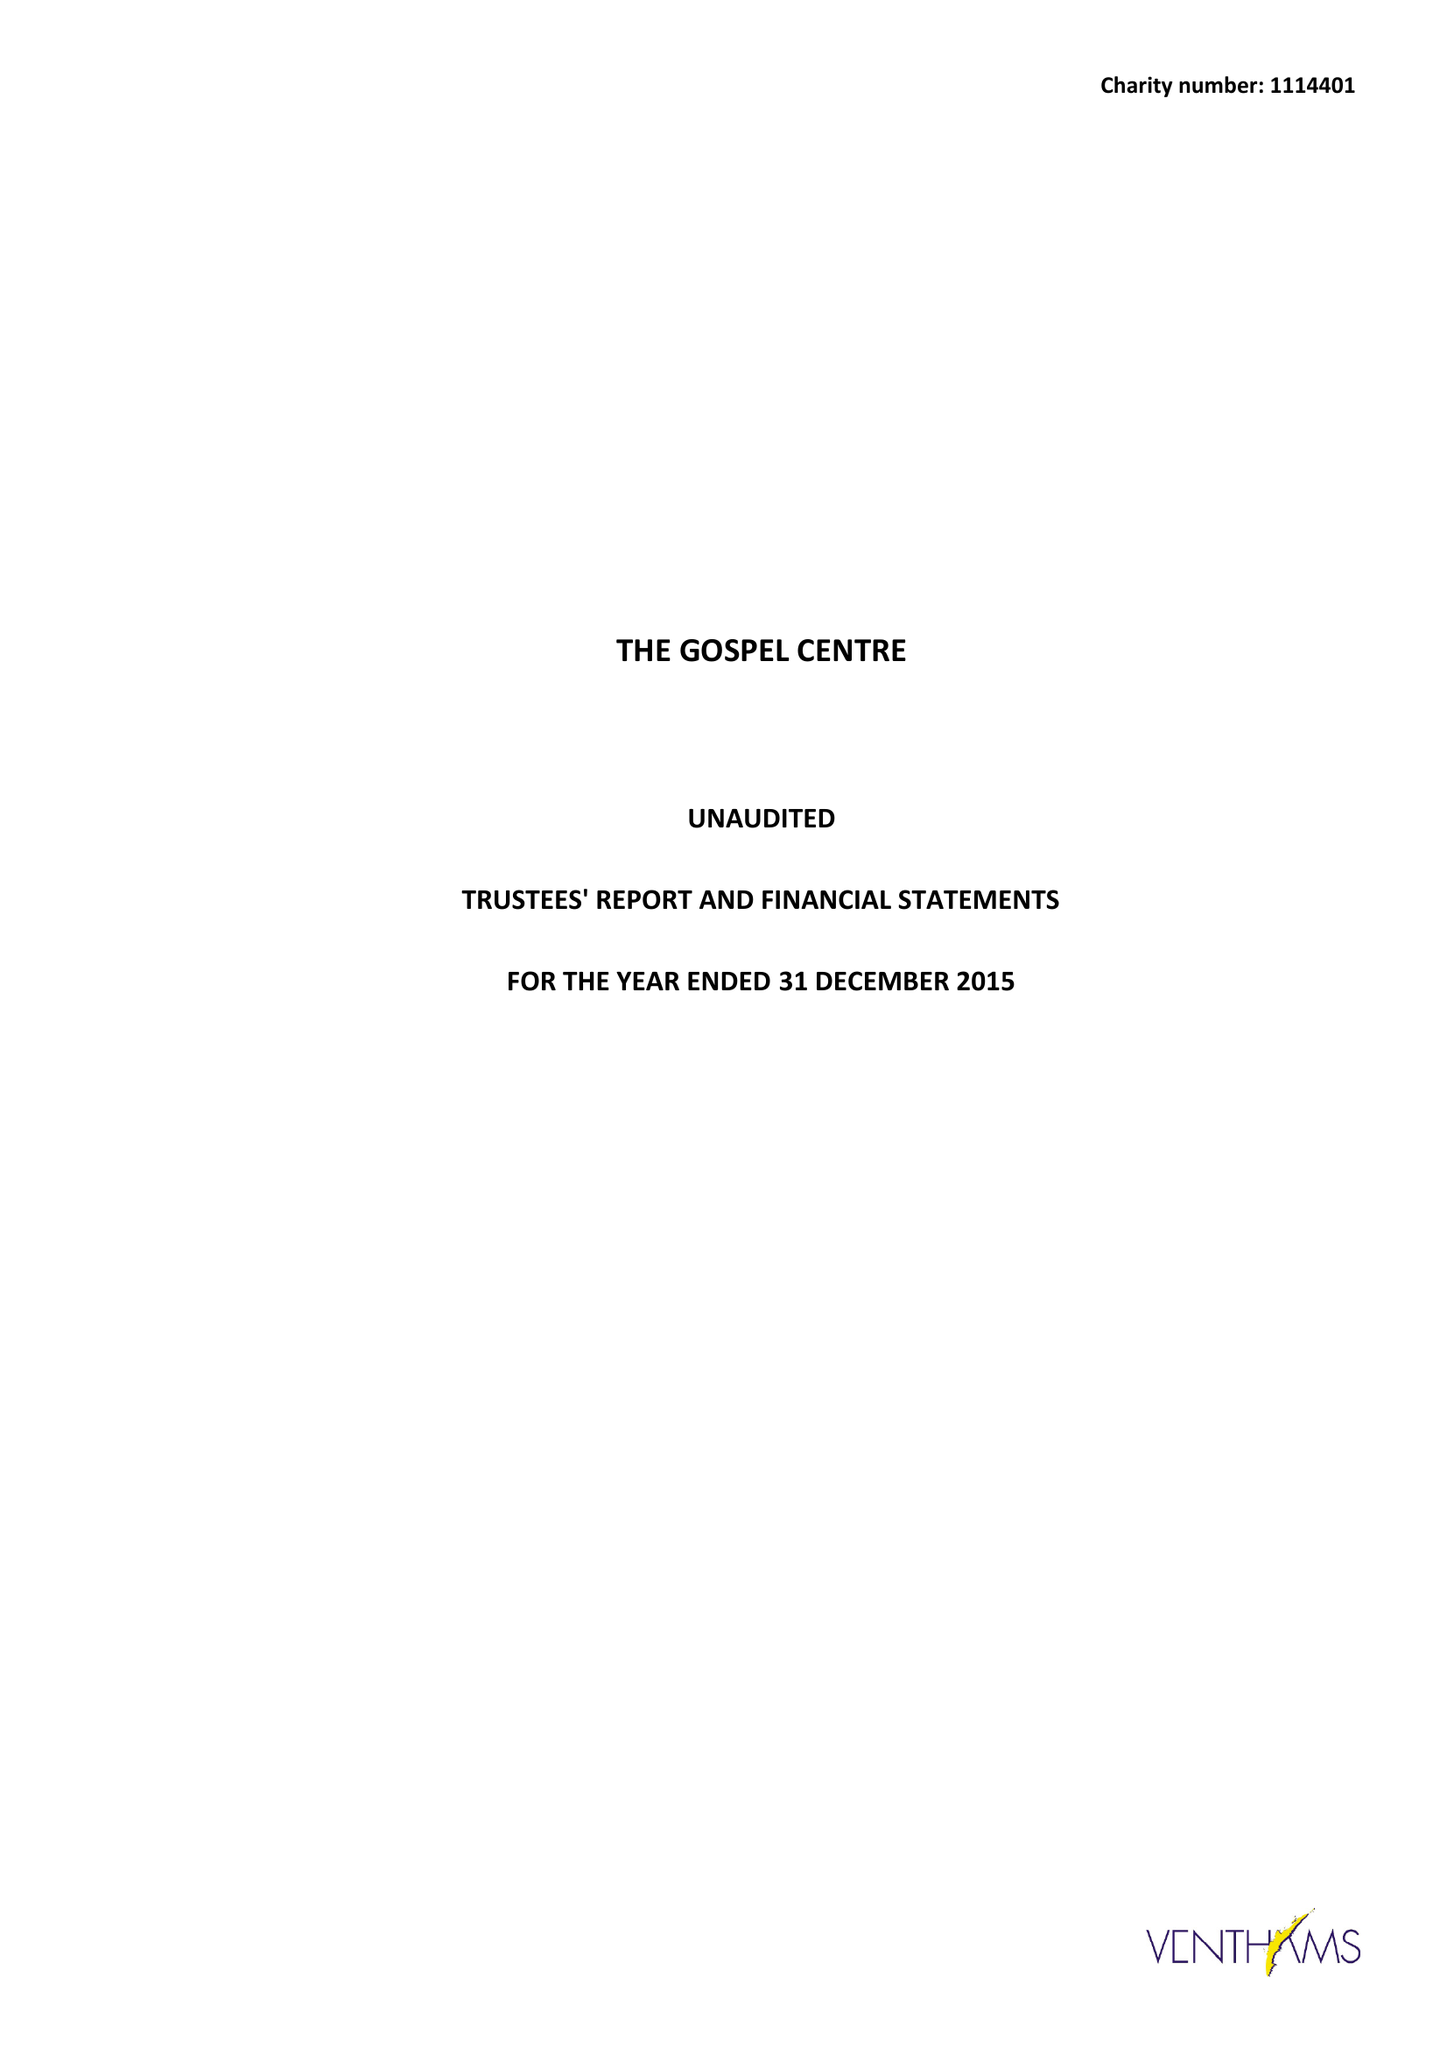What is the value for the income_annually_in_british_pounds?
Answer the question using a single word or phrase. 140519.00 